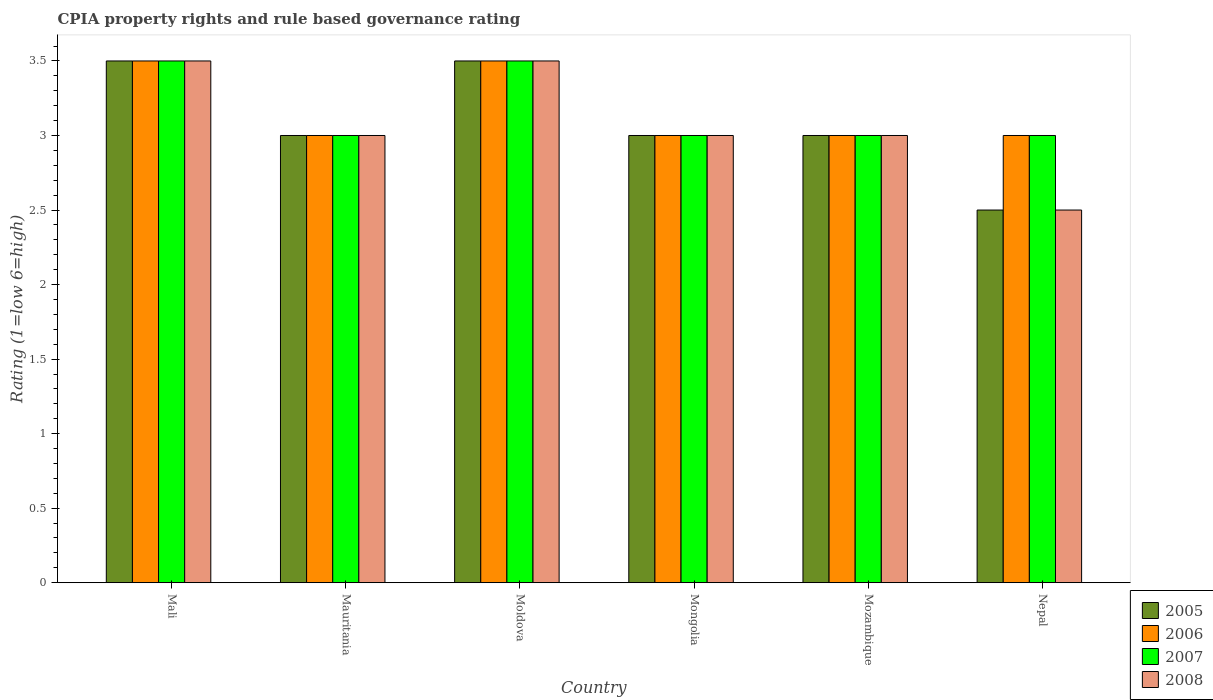How many different coloured bars are there?
Your answer should be very brief. 4. How many groups of bars are there?
Keep it short and to the point. 6. Are the number of bars per tick equal to the number of legend labels?
Your answer should be compact. Yes. Are the number of bars on each tick of the X-axis equal?
Your answer should be compact. Yes. How many bars are there on the 4th tick from the right?
Your answer should be very brief. 4. What is the label of the 4th group of bars from the left?
Offer a very short reply. Mongolia. What is the CPIA rating in 2008 in Mali?
Your response must be concise. 3.5. Across all countries, what is the minimum CPIA rating in 2007?
Ensure brevity in your answer.  3. In which country was the CPIA rating in 2006 maximum?
Give a very brief answer. Mali. In which country was the CPIA rating in 2006 minimum?
Offer a very short reply. Mauritania. What is the average CPIA rating in 2005 per country?
Offer a very short reply. 3.08. What is the difference between the CPIA rating of/in 2005 and CPIA rating of/in 2006 in Nepal?
Your answer should be very brief. -0.5. In how many countries, is the CPIA rating in 2008 greater than 1?
Provide a succinct answer. 6. What is the ratio of the CPIA rating in 2006 in Mali to that in Mongolia?
Offer a very short reply. 1.17. What is the difference between the highest and the second highest CPIA rating in 2008?
Offer a terse response. -0.5. What is the difference between the highest and the lowest CPIA rating in 2006?
Keep it short and to the point. 0.5. Is the sum of the CPIA rating in 2008 in Mauritania and Moldova greater than the maximum CPIA rating in 2007 across all countries?
Your response must be concise. Yes. How many bars are there?
Offer a very short reply. 24. Where does the legend appear in the graph?
Offer a very short reply. Bottom right. How are the legend labels stacked?
Make the answer very short. Vertical. What is the title of the graph?
Provide a succinct answer. CPIA property rights and rule based governance rating. What is the label or title of the Y-axis?
Provide a short and direct response. Rating (1=low 6=high). What is the Rating (1=low 6=high) of 2005 in Mongolia?
Your answer should be compact. 3. What is the Rating (1=low 6=high) of 2007 in Mongolia?
Provide a succinct answer. 3. What is the Rating (1=low 6=high) in 2008 in Mongolia?
Offer a very short reply. 3. Across all countries, what is the maximum Rating (1=low 6=high) of 2006?
Provide a short and direct response. 3.5. Across all countries, what is the maximum Rating (1=low 6=high) of 2007?
Ensure brevity in your answer.  3.5. Across all countries, what is the minimum Rating (1=low 6=high) of 2006?
Keep it short and to the point. 3. What is the total Rating (1=low 6=high) in 2005 in the graph?
Your response must be concise. 18.5. What is the total Rating (1=low 6=high) of 2007 in the graph?
Offer a very short reply. 19. What is the total Rating (1=low 6=high) of 2008 in the graph?
Provide a succinct answer. 18.5. What is the difference between the Rating (1=low 6=high) of 2005 in Mali and that in Mauritania?
Keep it short and to the point. 0.5. What is the difference between the Rating (1=low 6=high) in 2005 in Mali and that in Moldova?
Offer a very short reply. 0. What is the difference between the Rating (1=low 6=high) in 2006 in Mali and that in Moldova?
Ensure brevity in your answer.  0. What is the difference between the Rating (1=low 6=high) of 2008 in Mali and that in Moldova?
Your response must be concise. 0. What is the difference between the Rating (1=low 6=high) in 2005 in Mali and that in Mongolia?
Your answer should be very brief. 0.5. What is the difference between the Rating (1=low 6=high) of 2006 in Mali and that in Mongolia?
Your response must be concise. 0.5. What is the difference between the Rating (1=low 6=high) in 2007 in Mali and that in Mongolia?
Offer a terse response. 0.5. What is the difference between the Rating (1=low 6=high) of 2008 in Mali and that in Mongolia?
Provide a succinct answer. 0.5. What is the difference between the Rating (1=low 6=high) in 2005 in Mali and that in Mozambique?
Make the answer very short. 0.5. What is the difference between the Rating (1=low 6=high) in 2006 in Mali and that in Mozambique?
Provide a succinct answer. 0.5. What is the difference between the Rating (1=low 6=high) in 2007 in Mali and that in Mozambique?
Your response must be concise. 0.5. What is the difference between the Rating (1=low 6=high) of 2006 in Mali and that in Nepal?
Your answer should be very brief. 0.5. What is the difference between the Rating (1=low 6=high) in 2007 in Mali and that in Nepal?
Your response must be concise. 0.5. What is the difference between the Rating (1=low 6=high) in 2008 in Mali and that in Nepal?
Your response must be concise. 1. What is the difference between the Rating (1=low 6=high) in 2005 in Mauritania and that in Moldova?
Offer a terse response. -0.5. What is the difference between the Rating (1=low 6=high) of 2006 in Mauritania and that in Moldova?
Offer a terse response. -0.5. What is the difference between the Rating (1=low 6=high) in 2007 in Mauritania and that in Moldova?
Your response must be concise. -0.5. What is the difference between the Rating (1=low 6=high) of 2008 in Mauritania and that in Moldova?
Make the answer very short. -0.5. What is the difference between the Rating (1=low 6=high) of 2006 in Mauritania and that in Mongolia?
Provide a short and direct response. 0. What is the difference between the Rating (1=low 6=high) in 2005 in Mauritania and that in Mozambique?
Make the answer very short. 0. What is the difference between the Rating (1=low 6=high) in 2006 in Mauritania and that in Mozambique?
Provide a succinct answer. 0. What is the difference between the Rating (1=low 6=high) of 2007 in Mauritania and that in Mozambique?
Your response must be concise. 0. What is the difference between the Rating (1=low 6=high) in 2008 in Mauritania and that in Mozambique?
Make the answer very short. 0. What is the difference between the Rating (1=low 6=high) of 2006 in Mauritania and that in Nepal?
Provide a short and direct response. 0. What is the difference between the Rating (1=low 6=high) in 2008 in Mauritania and that in Nepal?
Make the answer very short. 0.5. What is the difference between the Rating (1=low 6=high) in 2005 in Moldova and that in Mongolia?
Offer a very short reply. 0.5. What is the difference between the Rating (1=low 6=high) in 2007 in Moldova and that in Mongolia?
Provide a succinct answer. 0.5. What is the difference between the Rating (1=low 6=high) in 2005 in Moldova and that in Mozambique?
Keep it short and to the point. 0.5. What is the difference between the Rating (1=low 6=high) in 2006 in Moldova and that in Mozambique?
Your answer should be very brief. 0.5. What is the difference between the Rating (1=low 6=high) of 2007 in Mongolia and that in Mozambique?
Make the answer very short. 0. What is the difference between the Rating (1=low 6=high) in 2006 in Mongolia and that in Nepal?
Your response must be concise. 0. What is the difference between the Rating (1=low 6=high) of 2007 in Mongolia and that in Nepal?
Offer a very short reply. 0. What is the difference between the Rating (1=low 6=high) in 2008 in Mongolia and that in Nepal?
Provide a short and direct response. 0.5. What is the difference between the Rating (1=low 6=high) of 2005 in Mozambique and that in Nepal?
Ensure brevity in your answer.  0.5. What is the difference between the Rating (1=low 6=high) of 2006 in Mozambique and that in Nepal?
Keep it short and to the point. 0. What is the difference between the Rating (1=low 6=high) in 2005 in Mali and the Rating (1=low 6=high) in 2008 in Mauritania?
Make the answer very short. 0.5. What is the difference between the Rating (1=low 6=high) in 2007 in Mali and the Rating (1=low 6=high) in 2008 in Mauritania?
Offer a very short reply. 0.5. What is the difference between the Rating (1=low 6=high) in 2005 in Mali and the Rating (1=low 6=high) in 2008 in Moldova?
Provide a succinct answer. 0. What is the difference between the Rating (1=low 6=high) in 2007 in Mali and the Rating (1=low 6=high) in 2008 in Moldova?
Keep it short and to the point. 0. What is the difference between the Rating (1=low 6=high) of 2005 in Mali and the Rating (1=low 6=high) of 2006 in Mongolia?
Your response must be concise. 0.5. What is the difference between the Rating (1=low 6=high) in 2005 in Mali and the Rating (1=low 6=high) in 2007 in Mongolia?
Offer a terse response. 0.5. What is the difference between the Rating (1=low 6=high) in 2005 in Mali and the Rating (1=low 6=high) in 2008 in Mongolia?
Your answer should be compact. 0.5. What is the difference between the Rating (1=low 6=high) in 2006 in Mali and the Rating (1=low 6=high) in 2007 in Mongolia?
Make the answer very short. 0.5. What is the difference between the Rating (1=low 6=high) in 2005 in Mali and the Rating (1=low 6=high) in 2008 in Mozambique?
Make the answer very short. 0.5. What is the difference between the Rating (1=low 6=high) in 2005 in Mali and the Rating (1=low 6=high) in 2007 in Nepal?
Your response must be concise. 0.5. What is the difference between the Rating (1=low 6=high) of 2007 in Mali and the Rating (1=low 6=high) of 2008 in Nepal?
Offer a terse response. 1. What is the difference between the Rating (1=low 6=high) in 2005 in Mauritania and the Rating (1=low 6=high) in 2006 in Moldova?
Offer a terse response. -0.5. What is the difference between the Rating (1=low 6=high) in 2005 in Mauritania and the Rating (1=low 6=high) in 2007 in Moldova?
Give a very brief answer. -0.5. What is the difference between the Rating (1=low 6=high) in 2005 in Mauritania and the Rating (1=low 6=high) in 2008 in Moldova?
Keep it short and to the point. -0.5. What is the difference between the Rating (1=low 6=high) in 2007 in Mauritania and the Rating (1=low 6=high) in 2008 in Moldova?
Make the answer very short. -0.5. What is the difference between the Rating (1=low 6=high) of 2006 in Mauritania and the Rating (1=low 6=high) of 2007 in Mongolia?
Provide a short and direct response. 0. What is the difference between the Rating (1=low 6=high) of 2006 in Mauritania and the Rating (1=low 6=high) of 2008 in Mongolia?
Keep it short and to the point. 0. What is the difference between the Rating (1=low 6=high) in 2006 in Mauritania and the Rating (1=low 6=high) in 2007 in Mozambique?
Your answer should be very brief. 0. What is the difference between the Rating (1=low 6=high) of 2006 in Mauritania and the Rating (1=low 6=high) of 2008 in Mozambique?
Your response must be concise. 0. What is the difference between the Rating (1=low 6=high) of 2005 in Mauritania and the Rating (1=low 6=high) of 2006 in Nepal?
Your answer should be compact. 0. What is the difference between the Rating (1=low 6=high) in 2005 in Mauritania and the Rating (1=low 6=high) in 2007 in Nepal?
Offer a terse response. 0. What is the difference between the Rating (1=low 6=high) in 2006 in Mauritania and the Rating (1=low 6=high) in 2007 in Nepal?
Offer a very short reply. 0. What is the difference between the Rating (1=low 6=high) in 2006 in Mauritania and the Rating (1=low 6=high) in 2008 in Nepal?
Ensure brevity in your answer.  0.5. What is the difference between the Rating (1=low 6=high) in 2007 in Mauritania and the Rating (1=low 6=high) in 2008 in Nepal?
Offer a terse response. 0.5. What is the difference between the Rating (1=low 6=high) of 2005 in Moldova and the Rating (1=low 6=high) of 2008 in Mongolia?
Provide a short and direct response. 0.5. What is the difference between the Rating (1=low 6=high) in 2006 in Moldova and the Rating (1=low 6=high) in 2008 in Mongolia?
Keep it short and to the point. 0.5. What is the difference between the Rating (1=low 6=high) in 2007 in Moldova and the Rating (1=low 6=high) in 2008 in Mongolia?
Your response must be concise. 0.5. What is the difference between the Rating (1=low 6=high) of 2005 in Moldova and the Rating (1=low 6=high) of 2007 in Mozambique?
Your answer should be compact. 0.5. What is the difference between the Rating (1=low 6=high) of 2005 in Moldova and the Rating (1=low 6=high) of 2007 in Nepal?
Provide a short and direct response. 0.5. What is the difference between the Rating (1=low 6=high) of 2006 in Moldova and the Rating (1=low 6=high) of 2007 in Nepal?
Provide a short and direct response. 0.5. What is the difference between the Rating (1=low 6=high) in 2007 in Moldova and the Rating (1=low 6=high) in 2008 in Nepal?
Make the answer very short. 1. What is the difference between the Rating (1=low 6=high) in 2005 in Mongolia and the Rating (1=low 6=high) in 2006 in Mozambique?
Give a very brief answer. 0. What is the difference between the Rating (1=low 6=high) in 2005 in Mongolia and the Rating (1=low 6=high) in 2008 in Mozambique?
Your response must be concise. 0. What is the difference between the Rating (1=low 6=high) of 2006 in Mongolia and the Rating (1=low 6=high) of 2007 in Mozambique?
Ensure brevity in your answer.  0. What is the difference between the Rating (1=low 6=high) of 2007 in Mongolia and the Rating (1=low 6=high) of 2008 in Mozambique?
Make the answer very short. 0. What is the difference between the Rating (1=low 6=high) of 2005 in Mongolia and the Rating (1=low 6=high) of 2007 in Nepal?
Your answer should be very brief. 0. What is the difference between the Rating (1=low 6=high) of 2005 in Mongolia and the Rating (1=low 6=high) of 2008 in Nepal?
Offer a terse response. 0.5. What is the difference between the Rating (1=low 6=high) in 2005 in Mozambique and the Rating (1=low 6=high) in 2007 in Nepal?
Provide a short and direct response. 0. What is the difference between the Rating (1=low 6=high) of 2006 in Mozambique and the Rating (1=low 6=high) of 2008 in Nepal?
Offer a very short reply. 0.5. What is the difference between the Rating (1=low 6=high) of 2007 in Mozambique and the Rating (1=low 6=high) of 2008 in Nepal?
Offer a terse response. 0.5. What is the average Rating (1=low 6=high) of 2005 per country?
Your response must be concise. 3.08. What is the average Rating (1=low 6=high) of 2006 per country?
Keep it short and to the point. 3.17. What is the average Rating (1=low 6=high) in 2007 per country?
Your response must be concise. 3.17. What is the average Rating (1=low 6=high) of 2008 per country?
Ensure brevity in your answer.  3.08. What is the difference between the Rating (1=low 6=high) of 2006 and Rating (1=low 6=high) of 2007 in Mali?
Give a very brief answer. 0. What is the difference between the Rating (1=low 6=high) of 2007 and Rating (1=low 6=high) of 2008 in Mali?
Give a very brief answer. 0. What is the difference between the Rating (1=low 6=high) in 2005 and Rating (1=low 6=high) in 2007 in Mauritania?
Make the answer very short. 0. What is the difference between the Rating (1=low 6=high) of 2006 and Rating (1=low 6=high) of 2007 in Mauritania?
Ensure brevity in your answer.  0. What is the difference between the Rating (1=low 6=high) of 2006 and Rating (1=low 6=high) of 2008 in Mauritania?
Provide a short and direct response. 0. What is the difference between the Rating (1=low 6=high) in 2005 and Rating (1=low 6=high) in 2007 in Moldova?
Provide a succinct answer. 0. What is the difference between the Rating (1=low 6=high) of 2007 and Rating (1=low 6=high) of 2008 in Moldova?
Ensure brevity in your answer.  0. What is the difference between the Rating (1=low 6=high) of 2005 and Rating (1=low 6=high) of 2008 in Mongolia?
Your response must be concise. 0. What is the difference between the Rating (1=low 6=high) in 2006 and Rating (1=low 6=high) in 2007 in Mongolia?
Your answer should be very brief. 0. What is the difference between the Rating (1=low 6=high) of 2007 and Rating (1=low 6=high) of 2008 in Mongolia?
Your answer should be very brief. 0. What is the difference between the Rating (1=low 6=high) of 2005 and Rating (1=low 6=high) of 2007 in Mozambique?
Give a very brief answer. 0. What is the difference between the Rating (1=low 6=high) of 2007 and Rating (1=low 6=high) of 2008 in Mozambique?
Offer a terse response. 0. What is the difference between the Rating (1=low 6=high) in 2005 and Rating (1=low 6=high) in 2007 in Nepal?
Keep it short and to the point. -0.5. What is the ratio of the Rating (1=low 6=high) in 2007 in Mali to that in Mauritania?
Provide a succinct answer. 1.17. What is the ratio of the Rating (1=low 6=high) in 2005 in Mali to that in Moldova?
Provide a succinct answer. 1. What is the ratio of the Rating (1=low 6=high) in 2006 in Mali to that in Moldova?
Provide a succinct answer. 1. What is the ratio of the Rating (1=low 6=high) of 2007 in Mali to that in Moldova?
Your answer should be compact. 1. What is the ratio of the Rating (1=low 6=high) in 2008 in Mali to that in Moldova?
Ensure brevity in your answer.  1. What is the ratio of the Rating (1=low 6=high) in 2007 in Mali to that in Mongolia?
Make the answer very short. 1.17. What is the ratio of the Rating (1=low 6=high) of 2008 in Mali to that in Mongolia?
Your answer should be compact. 1.17. What is the ratio of the Rating (1=low 6=high) of 2007 in Mali to that in Mozambique?
Provide a short and direct response. 1.17. What is the ratio of the Rating (1=low 6=high) in 2008 in Mali to that in Mozambique?
Provide a succinct answer. 1.17. What is the ratio of the Rating (1=low 6=high) in 2007 in Mali to that in Nepal?
Offer a terse response. 1.17. What is the ratio of the Rating (1=low 6=high) of 2008 in Mali to that in Nepal?
Offer a terse response. 1.4. What is the ratio of the Rating (1=low 6=high) in 2005 in Mauritania to that in Moldova?
Your answer should be very brief. 0.86. What is the ratio of the Rating (1=low 6=high) of 2006 in Mauritania to that in Moldova?
Provide a succinct answer. 0.86. What is the ratio of the Rating (1=low 6=high) of 2007 in Mauritania to that in Moldova?
Offer a very short reply. 0.86. What is the ratio of the Rating (1=low 6=high) of 2006 in Mauritania to that in Mozambique?
Offer a very short reply. 1. What is the ratio of the Rating (1=low 6=high) in 2008 in Mauritania to that in Mozambique?
Offer a terse response. 1. What is the ratio of the Rating (1=low 6=high) in 2007 in Mauritania to that in Nepal?
Offer a terse response. 1. What is the ratio of the Rating (1=low 6=high) of 2008 in Mauritania to that in Nepal?
Offer a terse response. 1.2. What is the ratio of the Rating (1=low 6=high) of 2007 in Moldova to that in Mongolia?
Your answer should be very brief. 1.17. What is the ratio of the Rating (1=low 6=high) of 2005 in Moldova to that in Mozambique?
Your answer should be compact. 1.17. What is the ratio of the Rating (1=low 6=high) in 2006 in Moldova to that in Mozambique?
Provide a short and direct response. 1.17. What is the ratio of the Rating (1=low 6=high) in 2008 in Moldova to that in Mozambique?
Offer a very short reply. 1.17. What is the ratio of the Rating (1=low 6=high) in 2005 in Moldova to that in Nepal?
Offer a terse response. 1.4. What is the ratio of the Rating (1=low 6=high) in 2006 in Moldova to that in Nepal?
Provide a short and direct response. 1.17. What is the ratio of the Rating (1=low 6=high) of 2008 in Moldova to that in Nepal?
Offer a terse response. 1.4. What is the ratio of the Rating (1=low 6=high) of 2006 in Mongolia to that in Mozambique?
Make the answer very short. 1. What is the ratio of the Rating (1=low 6=high) of 2007 in Mongolia to that in Mozambique?
Keep it short and to the point. 1. What is the ratio of the Rating (1=low 6=high) of 2008 in Mongolia to that in Mozambique?
Ensure brevity in your answer.  1. What is the ratio of the Rating (1=low 6=high) of 2005 in Mongolia to that in Nepal?
Offer a very short reply. 1.2. What is the ratio of the Rating (1=low 6=high) in 2006 in Mongolia to that in Nepal?
Give a very brief answer. 1. What is the ratio of the Rating (1=low 6=high) in 2008 in Mongolia to that in Nepal?
Keep it short and to the point. 1.2. What is the ratio of the Rating (1=low 6=high) in 2005 in Mozambique to that in Nepal?
Offer a very short reply. 1.2. What is the difference between the highest and the second highest Rating (1=low 6=high) of 2005?
Ensure brevity in your answer.  0. What is the difference between the highest and the second highest Rating (1=low 6=high) of 2006?
Keep it short and to the point. 0. What is the difference between the highest and the second highest Rating (1=low 6=high) in 2007?
Provide a succinct answer. 0. 